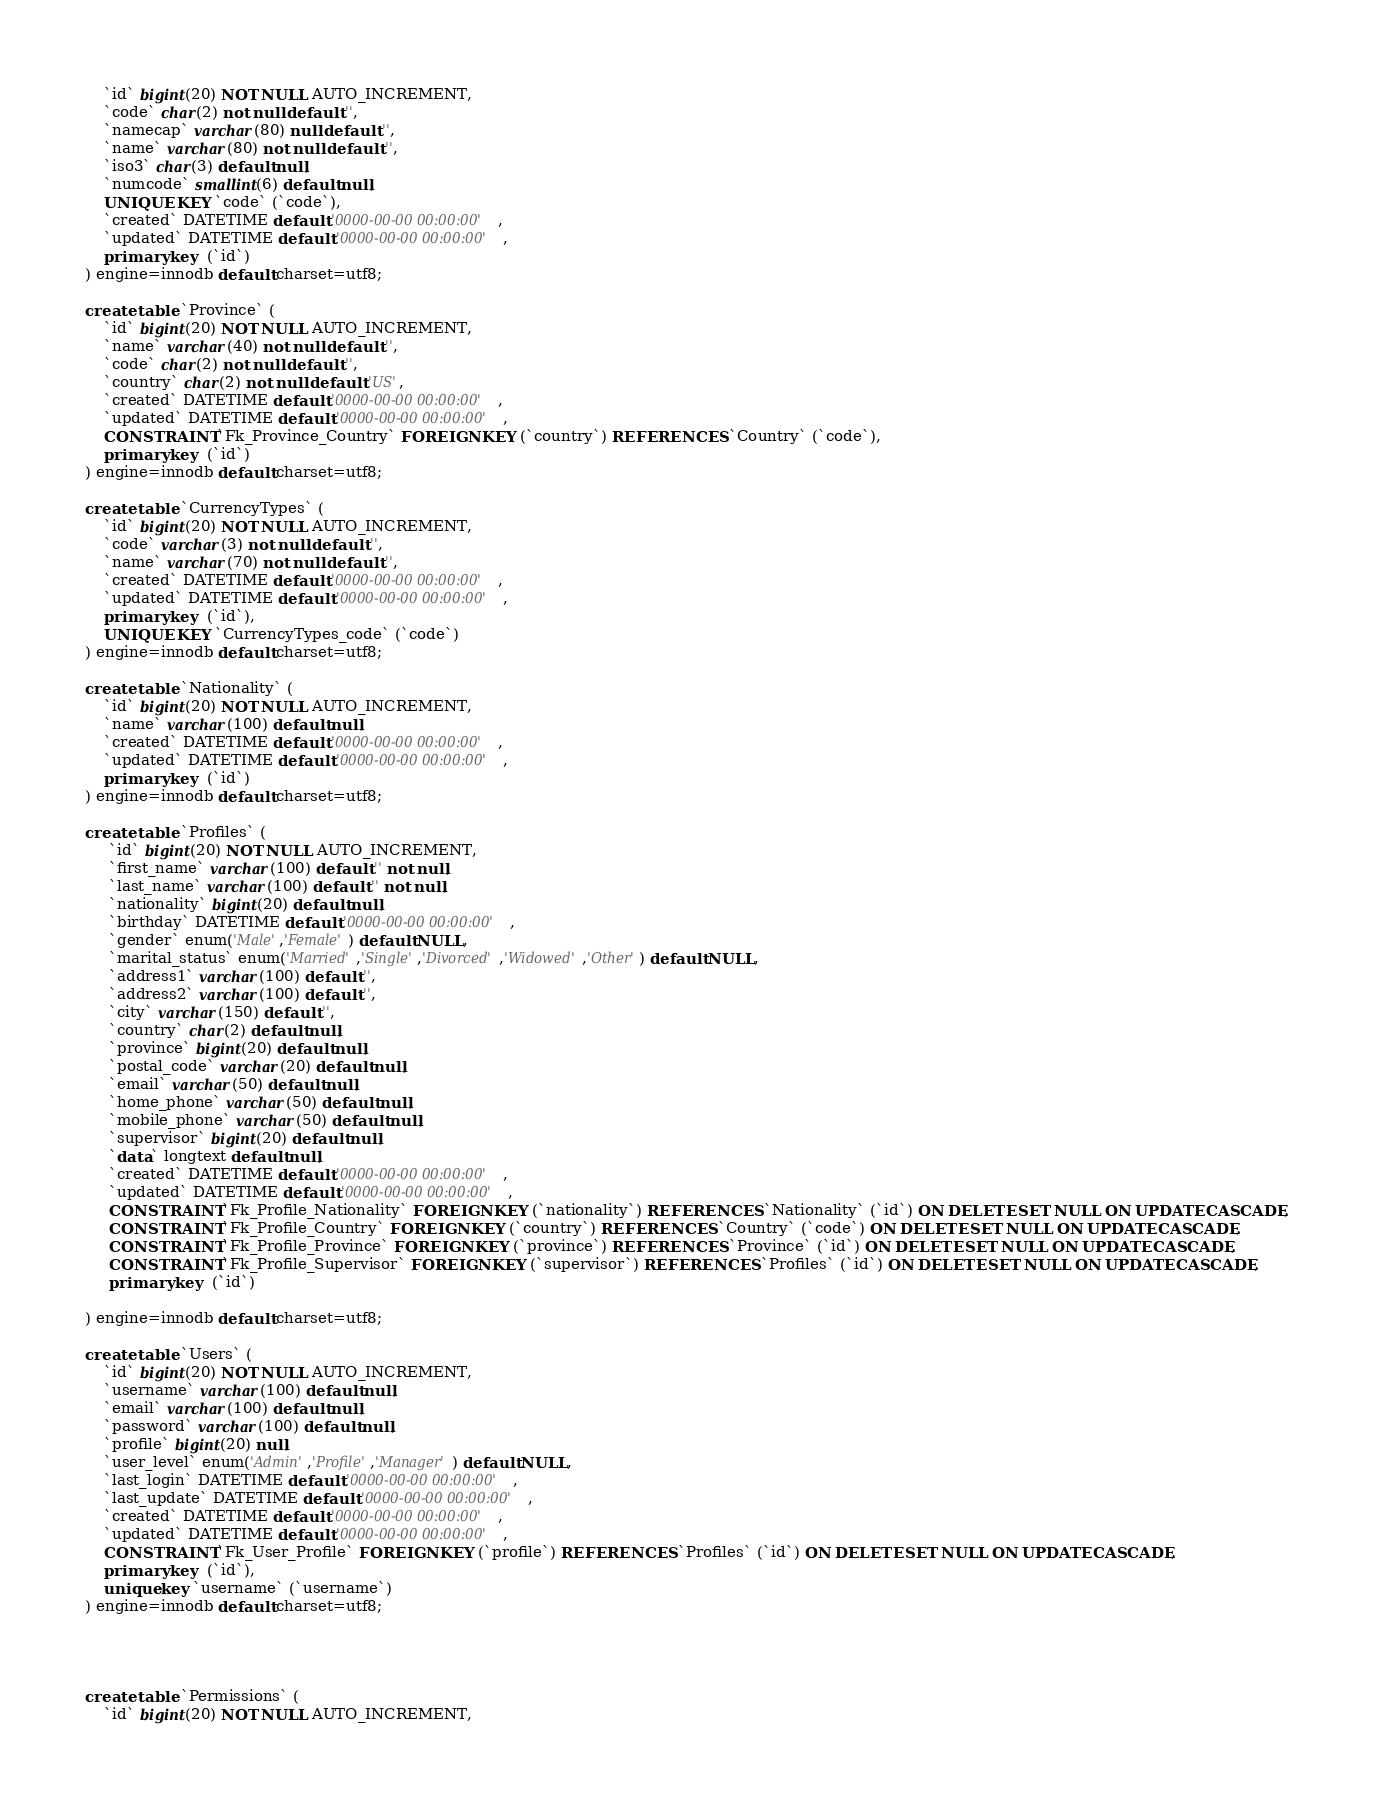<code> <loc_0><loc_0><loc_500><loc_500><_SQL_>	`id` bigint(20) NOT NULL AUTO_INCREMENT,
	`code` char(2) not null default '',
	`namecap` varchar(80) null default '',
	`name` varchar(80) not null default '',
	`iso3` char(3) default null,
	`numcode` smallint(6) default null,
	UNIQUE KEY `code` (`code`),
	`created` DATETIME default '0000-00-00 00:00:00',
	`updated` DATETIME default '0000-00-00 00:00:00',
	primary key  (`id`)
) engine=innodb default charset=utf8;

create table `Province` (
	`id` bigint(20) NOT NULL AUTO_INCREMENT,
	`name` varchar(40) not null default '',
	`code` char(2) not null default '',
	`country` char(2) not null default 'US',
	`created` DATETIME default '0000-00-00 00:00:00',
	`updated` DATETIME default '0000-00-00 00:00:00',
	CONSTRAINT `Fk_Province_Country` FOREIGN KEY (`country`) REFERENCES `Country` (`code`),
	primary key  (`id`)
) engine=innodb default charset=utf8;

create table `CurrencyTypes` (
	`id` bigint(20) NOT NULL AUTO_INCREMENT,
	`code` varchar(3) not null default '',
	`name` varchar(70) not null default '',
	`created` DATETIME default '0000-00-00 00:00:00',
	`updated` DATETIME default '0000-00-00 00:00:00',
	primary key  (`id`),
	UNIQUE KEY `CurrencyTypes_code` (`code`)
) engine=innodb default charset=utf8;

create table `Nationality` (
	`id` bigint(20) NOT NULL AUTO_INCREMENT,
	`name` varchar(100) default null,
	`created` DATETIME default '0000-00-00 00:00:00',
	`updated` DATETIME default '0000-00-00 00:00:00',
	primary key  (`id`)
) engine=innodb default charset=utf8;

create table `Profiles` (
	 `id` bigint(20) NOT NULL AUTO_INCREMENT,
	 `first_name` varchar(100) default '' not null,
	 `last_name` varchar(100) default '' not null,
	 `nationality` bigint(20) default null,
	 `birthday` DATETIME default '0000-00-00 00:00:00',
	 `gender` enum('Male','Female') default NULL,
	 `marital_status` enum('Married','Single','Divorced','Widowed','Other') default NULL,
	 `address1` varchar(100) default '',
	 `address2` varchar(100) default '',
	 `city` varchar(150) default '',
	 `country` char(2) default null,
	 `province` bigint(20) default null,
	 `postal_code` varchar(20) default null,
	 `email` varchar(50) default null,
	 `home_phone` varchar(50) default null,
	 `mobile_phone` varchar(50) default null,
	 `supervisor` bigint(20) default null,
	 `data` longtext default null,
	 `created` DATETIME default '0000-00-00 00:00:00',
	 `updated` DATETIME default '0000-00-00 00:00:00',
	 CONSTRAINT `Fk_Profile_Nationality` FOREIGN KEY (`nationality`) REFERENCES `Nationality` (`id`) ON DELETE SET NULL ON UPDATE CASCADE,
	 CONSTRAINT `Fk_Profile_Country` FOREIGN KEY (`country`) REFERENCES `Country` (`code`) ON DELETE SET NULL ON UPDATE CASCADE,
	 CONSTRAINT `Fk_Profile_Province` FOREIGN KEY (`province`) REFERENCES `Province` (`id`) ON DELETE SET NULL ON UPDATE CASCADE,
	 CONSTRAINT `Fk_Profile_Supervisor` FOREIGN KEY (`supervisor`) REFERENCES `Profiles` (`id`) ON DELETE SET NULL ON UPDATE CASCADE,
	 primary key  (`id`)
	 
) engine=innodb default charset=utf8;

create table `Users` (
	`id` bigint(20) NOT NULL AUTO_INCREMENT,
	`username` varchar(100) default null,
	`email` varchar(100) default null,
	`password` varchar(100) default null,
	`profile` bigint(20) null,
	`user_level` enum('Admin','Profile','Manager') default NULL,
	`last_login` DATETIME default '0000-00-00 00:00:00',
	`last_update` DATETIME default '0000-00-00 00:00:00',
	`created` DATETIME default '0000-00-00 00:00:00',
	`updated` DATETIME default '0000-00-00 00:00:00',
	CONSTRAINT `Fk_User_Profile` FOREIGN KEY (`profile`) REFERENCES `Profiles` (`id`) ON DELETE SET NULL ON UPDATE CASCADE,
	primary key  (`id`),
	unique key `username` (`username`)
) engine=innodb default charset=utf8;




create table `Permissions` (
	`id` bigint(20) NOT NULL AUTO_INCREMENT,</code> 